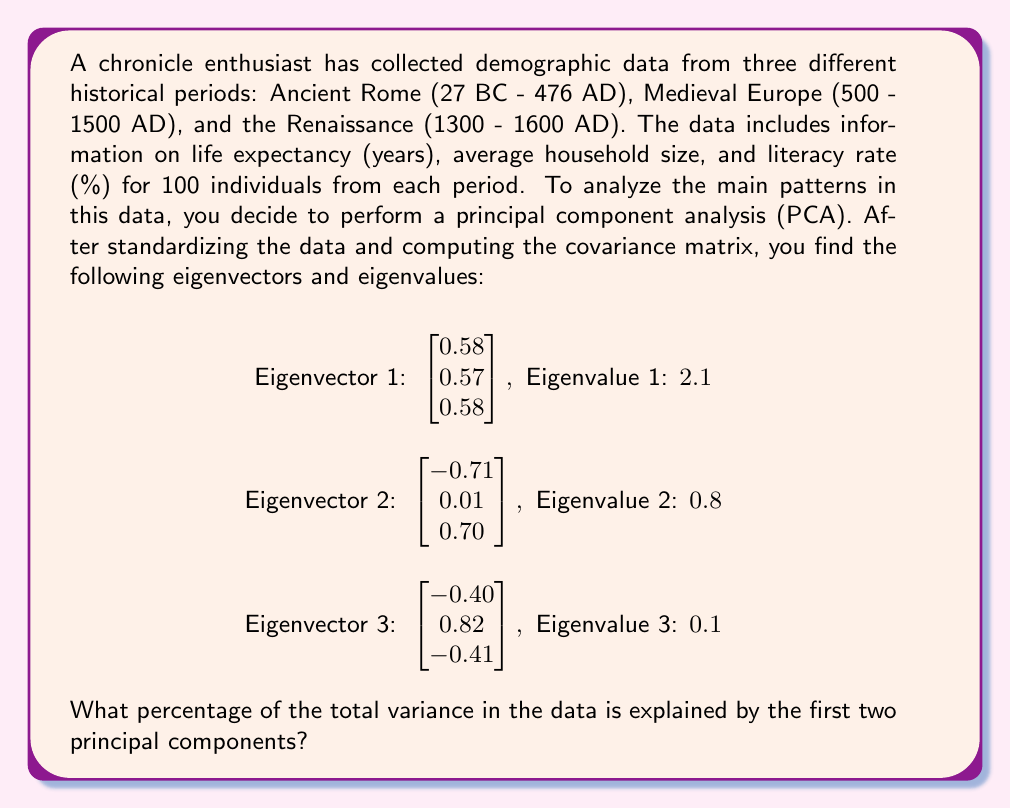Help me with this question. To solve this problem, we need to follow these steps:

1. Understand what the eigenvalues represent in PCA:
   In PCA, each eigenvalue represents the amount of variance explained by its corresponding principal component.

2. Calculate the total variance:
   The total variance is the sum of all eigenvalues.
   Total variance = $2.1 + 0.8 + 0.1 = 3.0$

3. Calculate the variance explained by the first two principal components:
   This is the sum of the first two eigenvalues.
   Variance explained by PC1 and PC2 = $2.1 + 0.8 = 2.9$

4. Calculate the percentage of variance explained:
   Percentage = (Variance explained by PC1 and PC2 / Total variance) * 100
   
   $\text{Percentage} = \frac{2.9}{3.0} * 100 = 96.67\%$

Therefore, the first two principal components explain 96.67% of the total variance in the data.

This high percentage indicates that the first two principal components capture most of the important patterns in the demographic data across the three historical periods. For a chronicle enthusiast, this means that these two components can provide a good summary of how life expectancy, household size, and literacy rates varied and were related across Ancient Rome, Medieval Europe, and the Renaissance.
Answer: 96.67% 